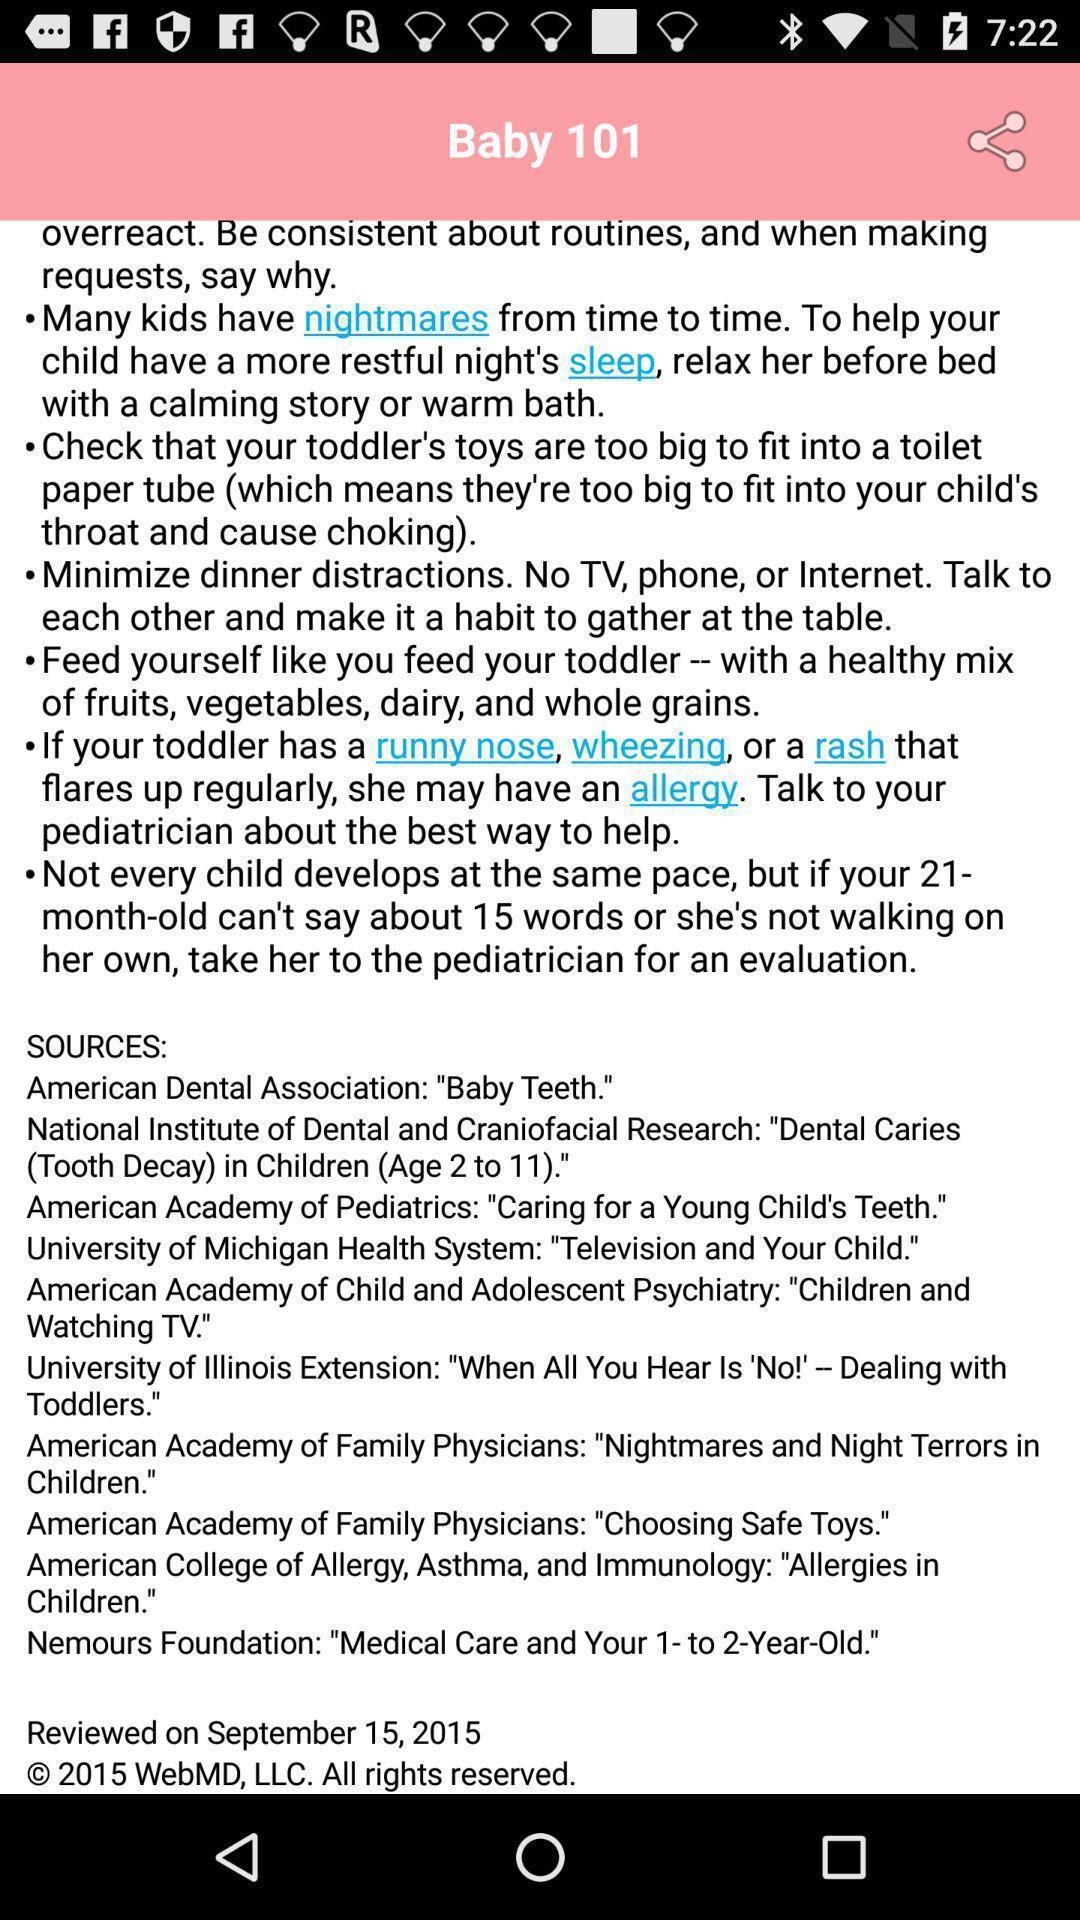Provide a textual representation of this image. Screen displaying information about an application. 